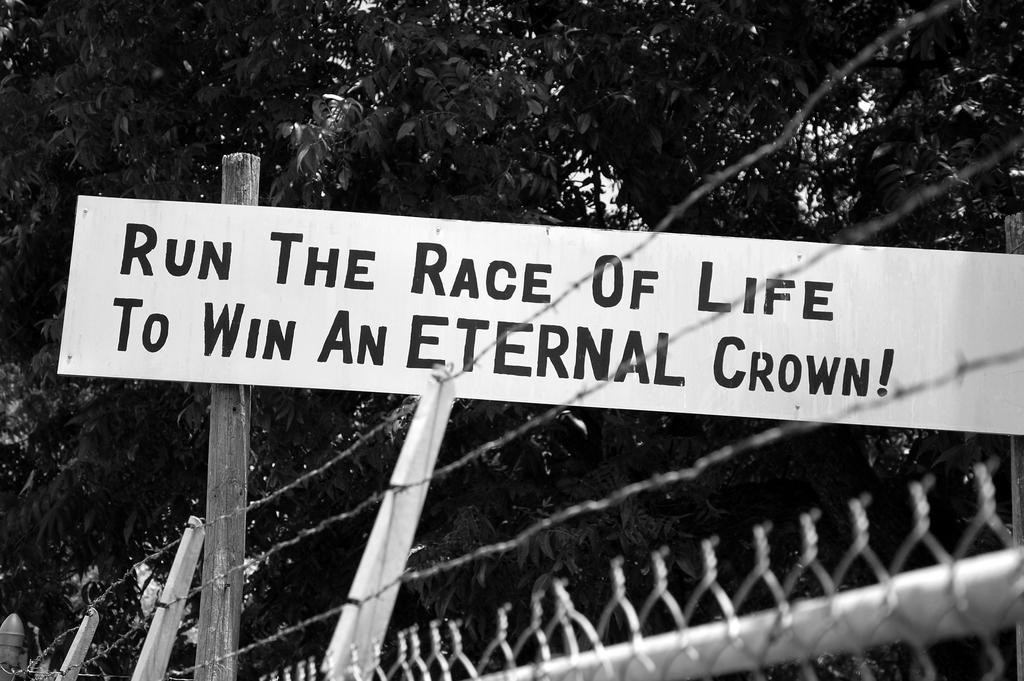What is the main object in the image? There is a board in the image. What is written or displayed on the board? There is text on the board. What type of structure can be seen in the image? There is a fence in the image. What other object is present in the image? There is a pole in the image. What can be seen in the background or surrounding the objects in the image? There are leaves visible in the image. What color is the shirt hanging on the pole in the image? There is no shirt hanging on the pole in the image; only a board, text, fence, pole, and leaves are present. 